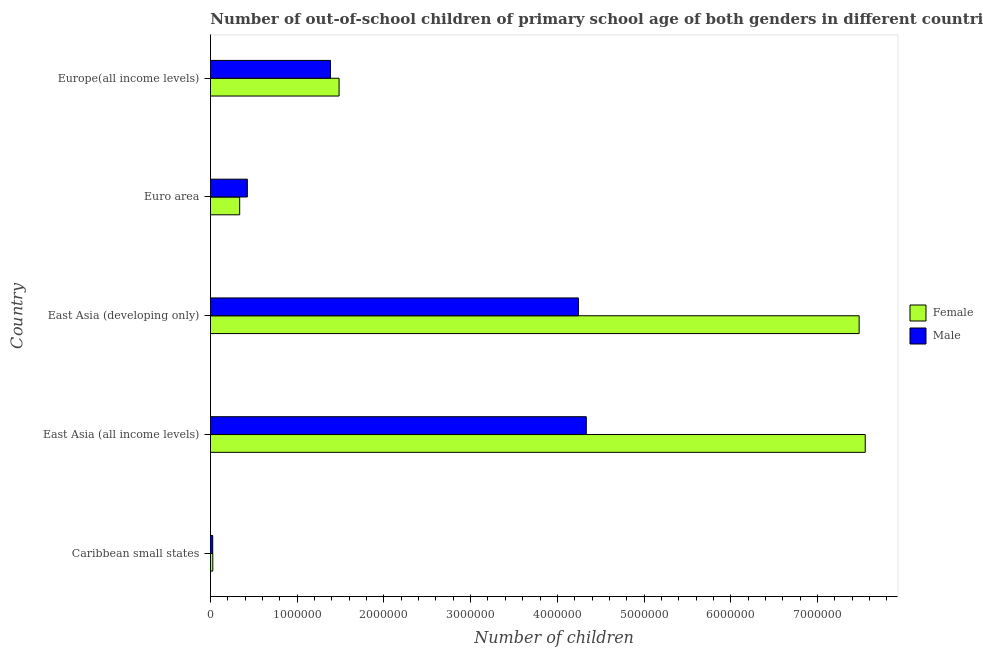How many groups of bars are there?
Your response must be concise. 5. Are the number of bars per tick equal to the number of legend labels?
Provide a succinct answer. Yes. Are the number of bars on each tick of the Y-axis equal?
Offer a terse response. Yes. What is the label of the 5th group of bars from the top?
Your answer should be very brief. Caribbean small states. What is the number of male out-of-school students in East Asia (developing only)?
Provide a succinct answer. 4.24e+06. Across all countries, what is the maximum number of female out-of-school students?
Ensure brevity in your answer.  7.55e+06. Across all countries, what is the minimum number of male out-of-school students?
Ensure brevity in your answer.  2.59e+04. In which country was the number of female out-of-school students maximum?
Your answer should be very brief. East Asia (all income levels). In which country was the number of male out-of-school students minimum?
Make the answer very short. Caribbean small states. What is the total number of male out-of-school students in the graph?
Make the answer very short. 1.04e+07. What is the difference between the number of male out-of-school students in East Asia (developing only) and that in Europe(all income levels)?
Your answer should be very brief. 2.86e+06. What is the difference between the number of female out-of-school students in East Asia (all income levels) and the number of male out-of-school students in East Asia (developing only)?
Your response must be concise. 3.31e+06. What is the average number of male out-of-school students per country?
Offer a very short reply. 2.08e+06. What is the difference between the number of female out-of-school students and number of male out-of-school students in Caribbean small states?
Provide a short and direct response. 766. In how many countries, is the number of male out-of-school students greater than 7200000 ?
Your answer should be very brief. 0. What is the ratio of the number of male out-of-school students in Caribbean small states to that in East Asia (developing only)?
Your response must be concise. 0.01. What is the difference between the highest and the second highest number of male out-of-school students?
Provide a succinct answer. 9.07e+04. What is the difference between the highest and the lowest number of female out-of-school students?
Offer a very short reply. 7.52e+06. What does the 2nd bar from the top in Euro area represents?
Keep it short and to the point. Female. What does the 2nd bar from the bottom in East Asia (all income levels) represents?
Offer a very short reply. Male. Are all the bars in the graph horizontal?
Your answer should be very brief. Yes. Are the values on the major ticks of X-axis written in scientific E-notation?
Offer a very short reply. No. Does the graph contain any zero values?
Your response must be concise. No. Does the graph contain grids?
Give a very brief answer. No. How many legend labels are there?
Your answer should be very brief. 2. How are the legend labels stacked?
Your response must be concise. Vertical. What is the title of the graph?
Offer a terse response. Number of out-of-school children of primary school age of both genders in different countries. What is the label or title of the X-axis?
Keep it short and to the point. Number of children. What is the Number of children in Female in Caribbean small states?
Give a very brief answer. 2.67e+04. What is the Number of children in Male in Caribbean small states?
Provide a short and direct response. 2.59e+04. What is the Number of children of Female in East Asia (all income levels)?
Give a very brief answer. 7.55e+06. What is the Number of children of Male in East Asia (all income levels)?
Provide a short and direct response. 4.33e+06. What is the Number of children of Female in East Asia (developing only)?
Keep it short and to the point. 7.48e+06. What is the Number of children of Male in East Asia (developing only)?
Ensure brevity in your answer.  4.24e+06. What is the Number of children in Female in Euro area?
Keep it short and to the point. 3.37e+05. What is the Number of children of Male in Euro area?
Your answer should be compact. 4.25e+05. What is the Number of children of Female in Europe(all income levels)?
Your answer should be compact. 1.48e+06. What is the Number of children of Male in Europe(all income levels)?
Ensure brevity in your answer.  1.38e+06. Across all countries, what is the maximum Number of children in Female?
Your answer should be very brief. 7.55e+06. Across all countries, what is the maximum Number of children in Male?
Make the answer very short. 4.33e+06. Across all countries, what is the minimum Number of children in Female?
Your answer should be very brief. 2.67e+04. Across all countries, what is the minimum Number of children of Male?
Ensure brevity in your answer.  2.59e+04. What is the total Number of children in Female in the graph?
Offer a terse response. 1.69e+07. What is the total Number of children in Male in the graph?
Keep it short and to the point. 1.04e+07. What is the difference between the Number of children of Female in Caribbean small states and that in East Asia (all income levels)?
Make the answer very short. -7.52e+06. What is the difference between the Number of children in Male in Caribbean small states and that in East Asia (all income levels)?
Your answer should be compact. -4.31e+06. What is the difference between the Number of children of Female in Caribbean small states and that in East Asia (developing only)?
Offer a terse response. -7.45e+06. What is the difference between the Number of children in Male in Caribbean small states and that in East Asia (developing only)?
Offer a very short reply. -4.22e+06. What is the difference between the Number of children in Female in Caribbean small states and that in Euro area?
Offer a terse response. -3.10e+05. What is the difference between the Number of children of Male in Caribbean small states and that in Euro area?
Make the answer very short. -3.99e+05. What is the difference between the Number of children in Female in Caribbean small states and that in Europe(all income levels)?
Your response must be concise. -1.46e+06. What is the difference between the Number of children in Male in Caribbean small states and that in Europe(all income levels)?
Your response must be concise. -1.36e+06. What is the difference between the Number of children in Female in East Asia (all income levels) and that in East Asia (developing only)?
Your response must be concise. 7.03e+04. What is the difference between the Number of children in Male in East Asia (all income levels) and that in East Asia (developing only)?
Ensure brevity in your answer.  9.07e+04. What is the difference between the Number of children in Female in East Asia (all income levels) and that in Euro area?
Provide a succinct answer. 7.21e+06. What is the difference between the Number of children in Male in East Asia (all income levels) and that in Euro area?
Make the answer very short. 3.91e+06. What is the difference between the Number of children in Female in East Asia (all income levels) and that in Europe(all income levels)?
Your response must be concise. 6.07e+06. What is the difference between the Number of children of Male in East Asia (all income levels) and that in Europe(all income levels)?
Keep it short and to the point. 2.95e+06. What is the difference between the Number of children of Female in East Asia (developing only) and that in Euro area?
Give a very brief answer. 7.14e+06. What is the difference between the Number of children of Male in East Asia (developing only) and that in Euro area?
Your answer should be compact. 3.82e+06. What is the difference between the Number of children in Female in East Asia (developing only) and that in Europe(all income levels)?
Your answer should be very brief. 6.00e+06. What is the difference between the Number of children in Male in East Asia (developing only) and that in Europe(all income levels)?
Your answer should be very brief. 2.86e+06. What is the difference between the Number of children in Female in Euro area and that in Europe(all income levels)?
Your answer should be very brief. -1.15e+06. What is the difference between the Number of children in Male in Euro area and that in Europe(all income levels)?
Provide a short and direct response. -9.58e+05. What is the difference between the Number of children of Female in Caribbean small states and the Number of children of Male in East Asia (all income levels)?
Ensure brevity in your answer.  -4.31e+06. What is the difference between the Number of children of Female in Caribbean small states and the Number of children of Male in East Asia (developing only)?
Ensure brevity in your answer.  -4.22e+06. What is the difference between the Number of children in Female in Caribbean small states and the Number of children in Male in Euro area?
Provide a short and direct response. -3.98e+05. What is the difference between the Number of children of Female in Caribbean small states and the Number of children of Male in Europe(all income levels)?
Provide a short and direct response. -1.36e+06. What is the difference between the Number of children in Female in East Asia (all income levels) and the Number of children in Male in East Asia (developing only)?
Make the answer very short. 3.31e+06. What is the difference between the Number of children in Female in East Asia (all income levels) and the Number of children in Male in Euro area?
Your response must be concise. 7.12e+06. What is the difference between the Number of children of Female in East Asia (all income levels) and the Number of children of Male in Europe(all income levels)?
Your answer should be compact. 6.17e+06. What is the difference between the Number of children in Female in East Asia (developing only) and the Number of children in Male in Euro area?
Your answer should be very brief. 7.05e+06. What is the difference between the Number of children of Female in East Asia (developing only) and the Number of children of Male in Europe(all income levels)?
Your answer should be very brief. 6.10e+06. What is the difference between the Number of children in Female in Euro area and the Number of children in Male in Europe(all income levels)?
Keep it short and to the point. -1.05e+06. What is the average Number of children of Female per country?
Give a very brief answer. 3.38e+06. What is the average Number of children in Male per country?
Provide a short and direct response. 2.08e+06. What is the difference between the Number of children in Female and Number of children in Male in Caribbean small states?
Make the answer very short. 766. What is the difference between the Number of children of Female and Number of children of Male in East Asia (all income levels)?
Provide a succinct answer. 3.22e+06. What is the difference between the Number of children of Female and Number of children of Male in East Asia (developing only)?
Ensure brevity in your answer.  3.24e+06. What is the difference between the Number of children of Female and Number of children of Male in Euro area?
Your answer should be very brief. -8.83e+04. What is the difference between the Number of children of Female and Number of children of Male in Europe(all income levels)?
Provide a succinct answer. 9.95e+04. What is the ratio of the Number of children in Female in Caribbean small states to that in East Asia (all income levels)?
Offer a very short reply. 0. What is the ratio of the Number of children in Male in Caribbean small states to that in East Asia (all income levels)?
Your answer should be compact. 0.01. What is the ratio of the Number of children of Female in Caribbean small states to that in East Asia (developing only)?
Provide a succinct answer. 0. What is the ratio of the Number of children of Male in Caribbean small states to that in East Asia (developing only)?
Your answer should be compact. 0.01. What is the ratio of the Number of children in Female in Caribbean small states to that in Euro area?
Ensure brevity in your answer.  0.08. What is the ratio of the Number of children of Male in Caribbean small states to that in Euro area?
Provide a succinct answer. 0.06. What is the ratio of the Number of children in Female in Caribbean small states to that in Europe(all income levels)?
Ensure brevity in your answer.  0.02. What is the ratio of the Number of children of Male in Caribbean small states to that in Europe(all income levels)?
Provide a succinct answer. 0.02. What is the ratio of the Number of children in Female in East Asia (all income levels) to that in East Asia (developing only)?
Provide a succinct answer. 1.01. What is the ratio of the Number of children of Male in East Asia (all income levels) to that in East Asia (developing only)?
Ensure brevity in your answer.  1.02. What is the ratio of the Number of children of Female in East Asia (all income levels) to that in Euro area?
Your response must be concise. 22.41. What is the ratio of the Number of children in Male in East Asia (all income levels) to that in Euro area?
Your answer should be compact. 10.19. What is the ratio of the Number of children of Female in East Asia (all income levels) to that in Europe(all income levels)?
Ensure brevity in your answer.  5.09. What is the ratio of the Number of children in Male in East Asia (all income levels) to that in Europe(all income levels)?
Your response must be concise. 3.13. What is the ratio of the Number of children in Female in East Asia (developing only) to that in Euro area?
Your answer should be very brief. 22.2. What is the ratio of the Number of children in Male in East Asia (developing only) to that in Euro area?
Provide a succinct answer. 9.98. What is the ratio of the Number of children in Female in East Asia (developing only) to that in Europe(all income levels)?
Your answer should be compact. 5.04. What is the ratio of the Number of children of Male in East Asia (developing only) to that in Europe(all income levels)?
Your answer should be compact. 3.07. What is the ratio of the Number of children of Female in Euro area to that in Europe(all income levels)?
Your response must be concise. 0.23. What is the ratio of the Number of children of Male in Euro area to that in Europe(all income levels)?
Your response must be concise. 0.31. What is the difference between the highest and the second highest Number of children of Female?
Your answer should be very brief. 7.03e+04. What is the difference between the highest and the second highest Number of children of Male?
Offer a very short reply. 9.07e+04. What is the difference between the highest and the lowest Number of children in Female?
Make the answer very short. 7.52e+06. What is the difference between the highest and the lowest Number of children of Male?
Offer a terse response. 4.31e+06. 